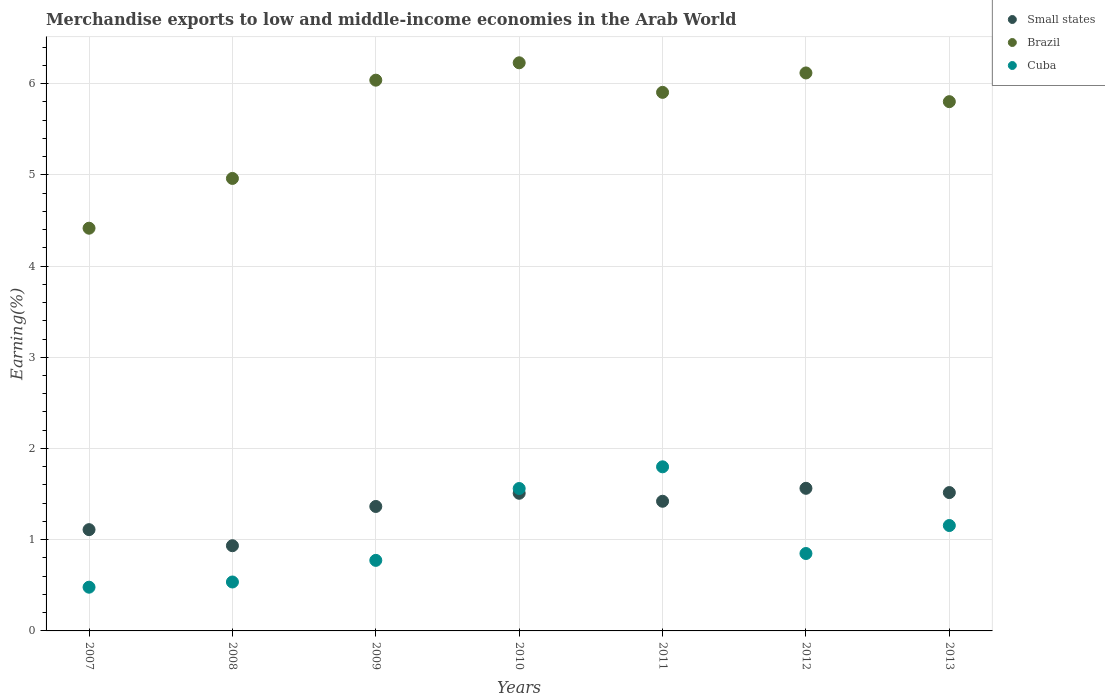What is the percentage of amount earned from merchandise exports in Small states in 2011?
Keep it short and to the point. 1.42. Across all years, what is the maximum percentage of amount earned from merchandise exports in Brazil?
Offer a terse response. 6.23. Across all years, what is the minimum percentage of amount earned from merchandise exports in Small states?
Offer a terse response. 0.93. In which year was the percentage of amount earned from merchandise exports in Brazil minimum?
Offer a very short reply. 2007. What is the total percentage of amount earned from merchandise exports in Small states in the graph?
Provide a succinct answer. 9.42. What is the difference between the percentage of amount earned from merchandise exports in Small states in 2011 and that in 2012?
Provide a succinct answer. -0.14. What is the difference between the percentage of amount earned from merchandise exports in Cuba in 2011 and the percentage of amount earned from merchandise exports in Small states in 2007?
Make the answer very short. 0.69. What is the average percentage of amount earned from merchandise exports in Small states per year?
Ensure brevity in your answer.  1.35. In the year 2013, what is the difference between the percentage of amount earned from merchandise exports in Brazil and percentage of amount earned from merchandise exports in Cuba?
Your answer should be compact. 4.65. What is the ratio of the percentage of amount earned from merchandise exports in Cuba in 2008 to that in 2011?
Your answer should be compact. 0.3. What is the difference between the highest and the second highest percentage of amount earned from merchandise exports in Brazil?
Provide a short and direct response. 0.11. What is the difference between the highest and the lowest percentage of amount earned from merchandise exports in Cuba?
Your answer should be very brief. 1.32. Is the percentage of amount earned from merchandise exports in Cuba strictly greater than the percentage of amount earned from merchandise exports in Small states over the years?
Keep it short and to the point. No. How many dotlines are there?
Give a very brief answer. 3. What is the difference between two consecutive major ticks on the Y-axis?
Ensure brevity in your answer.  1. Are the values on the major ticks of Y-axis written in scientific E-notation?
Offer a very short reply. No. Does the graph contain grids?
Your answer should be very brief. Yes. How are the legend labels stacked?
Provide a short and direct response. Vertical. What is the title of the graph?
Offer a terse response. Merchandise exports to low and middle-income economies in the Arab World. What is the label or title of the X-axis?
Your answer should be compact. Years. What is the label or title of the Y-axis?
Keep it short and to the point. Earning(%). What is the Earning(%) of Small states in 2007?
Provide a succinct answer. 1.11. What is the Earning(%) of Brazil in 2007?
Your answer should be very brief. 4.41. What is the Earning(%) of Cuba in 2007?
Offer a very short reply. 0.48. What is the Earning(%) in Small states in 2008?
Your answer should be compact. 0.93. What is the Earning(%) of Brazil in 2008?
Offer a terse response. 4.96. What is the Earning(%) of Cuba in 2008?
Make the answer very short. 0.54. What is the Earning(%) in Small states in 2009?
Your answer should be very brief. 1.36. What is the Earning(%) of Brazil in 2009?
Keep it short and to the point. 6.04. What is the Earning(%) of Cuba in 2009?
Keep it short and to the point. 0.77. What is the Earning(%) in Small states in 2010?
Provide a succinct answer. 1.51. What is the Earning(%) of Brazil in 2010?
Your answer should be compact. 6.23. What is the Earning(%) of Cuba in 2010?
Your response must be concise. 1.56. What is the Earning(%) of Small states in 2011?
Make the answer very short. 1.42. What is the Earning(%) of Brazil in 2011?
Make the answer very short. 5.9. What is the Earning(%) of Cuba in 2011?
Make the answer very short. 1.8. What is the Earning(%) in Small states in 2012?
Offer a very short reply. 1.56. What is the Earning(%) in Brazil in 2012?
Keep it short and to the point. 6.12. What is the Earning(%) in Cuba in 2012?
Offer a very short reply. 0.85. What is the Earning(%) in Small states in 2013?
Provide a succinct answer. 1.52. What is the Earning(%) of Brazil in 2013?
Make the answer very short. 5.8. What is the Earning(%) of Cuba in 2013?
Make the answer very short. 1.16. Across all years, what is the maximum Earning(%) of Small states?
Ensure brevity in your answer.  1.56. Across all years, what is the maximum Earning(%) of Brazil?
Keep it short and to the point. 6.23. Across all years, what is the maximum Earning(%) in Cuba?
Provide a short and direct response. 1.8. Across all years, what is the minimum Earning(%) of Small states?
Ensure brevity in your answer.  0.93. Across all years, what is the minimum Earning(%) in Brazil?
Your answer should be very brief. 4.41. Across all years, what is the minimum Earning(%) in Cuba?
Make the answer very short. 0.48. What is the total Earning(%) of Small states in the graph?
Your answer should be very brief. 9.42. What is the total Earning(%) of Brazil in the graph?
Offer a very short reply. 39.46. What is the total Earning(%) in Cuba in the graph?
Provide a succinct answer. 7.15. What is the difference between the Earning(%) of Small states in 2007 and that in 2008?
Provide a succinct answer. 0.18. What is the difference between the Earning(%) of Brazil in 2007 and that in 2008?
Keep it short and to the point. -0.55. What is the difference between the Earning(%) of Cuba in 2007 and that in 2008?
Your answer should be compact. -0.06. What is the difference between the Earning(%) in Small states in 2007 and that in 2009?
Provide a succinct answer. -0.25. What is the difference between the Earning(%) in Brazil in 2007 and that in 2009?
Your answer should be compact. -1.62. What is the difference between the Earning(%) of Cuba in 2007 and that in 2009?
Provide a succinct answer. -0.29. What is the difference between the Earning(%) of Small states in 2007 and that in 2010?
Your answer should be very brief. -0.4. What is the difference between the Earning(%) in Brazil in 2007 and that in 2010?
Provide a short and direct response. -1.81. What is the difference between the Earning(%) in Cuba in 2007 and that in 2010?
Provide a succinct answer. -1.08. What is the difference between the Earning(%) of Small states in 2007 and that in 2011?
Ensure brevity in your answer.  -0.31. What is the difference between the Earning(%) of Brazil in 2007 and that in 2011?
Your answer should be compact. -1.49. What is the difference between the Earning(%) in Cuba in 2007 and that in 2011?
Ensure brevity in your answer.  -1.32. What is the difference between the Earning(%) of Small states in 2007 and that in 2012?
Your answer should be very brief. -0.45. What is the difference between the Earning(%) of Brazil in 2007 and that in 2012?
Offer a terse response. -1.7. What is the difference between the Earning(%) of Cuba in 2007 and that in 2012?
Make the answer very short. -0.37. What is the difference between the Earning(%) of Small states in 2007 and that in 2013?
Offer a very short reply. -0.41. What is the difference between the Earning(%) in Brazil in 2007 and that in 2013?
Offer a very short reply. -1.39. What is the difference between the Earning(%) of Cuba in 2007 and that in 2013?
Give a very brief answer. -0.68. What is the difference between the Earning(%) of Small states in 2008 and that in 2009?
Give a very brief answer. -0.43. What is the difference between the Earning(%) of Brazil in 2008 and that in 2009?
Give a very brief answer. -1.08. What is the difference between the Earning(%) of Cuba in 2008 and that in 2009?
Your answer should be very brief. -0.24. What is the difference between the Earning(%) in Small states in 2008 and that in 2010?
Provide a short and direct response. -0.57. What is the difference between the Earning(%) in Brazil in 2008 and that in 2010?
Offer a terse response. -1.27. What is the difference between the Earning(%) of Cuba in 2008 and that in 2010?
Give a very brief answer. -1.02. What is the difference between the Earning(%) of Small states in 2008 and that in 2011?
Give a very brief answer. -0.49. What is the difference between the Earning(%) of Brazil in 2008 and that in 2011?
Give a very brief answer. -0.94. What is the difference between the Earning(%) in Cuba in 2008 and that in 2011?
Your response must be concise. -1.26. What is the difference between the Earning(%) in Small states in 2008 and that in 2012?
Provide a short and direct response. -0.63. What is the difference between the Earning(%) of Brazil in 2008 and that in 2012?
Offer a terse response. -1.16. What is the difference between the Earning(%) of Cuba in 2008 and that in 2012?
Make the answer very short. -0.31. What is the difference between the Earning(%) of Small states in 2008 and that in 2013?
Your answer should be very brief. -0.58. What is the difference between the Earning(%) of Brazil in 2008 and that in 2013?
Keep it short and to the point. -0.84. What is the difference between the Earning(%) of Cuba in 2008 and that in 2013?
Give a very brief answer. -0.62. What is the difference between the Earning(%) of Small states in 2009 and that in 2010?
Provide a succinct answer. -0.14. What is the difference between the Earning(%) in Brazil in 2009 and that in 2010?
Offer a very short reply. -0.19. What is the difference between the Earning(%) of Cuba in 2009 and that in 2010?
Keep it short and to the point. -0.79. What is the difference between the Earning(%) of Small states in 2009 and that in 2011?
Keep it short and to the point. -0.06. What is the difference between the Earning(%) of Brazil in 2009 and that in 2011?
Give a very brief answer. 0.13. What is the difference between the Earning(%) of Cuba in 2009 and that in 2011?
Offer a very short reply. -1.03. What is the difference between the Earning(%) of Small states in 2009 and that in 2012?
Your response must be concise. -0.2. What is the difference between the Earning(%) of Brazil in 2009 and that in 2012?
Provide a short and direct response. -0.08. What is the difference between the Earning(%) in Cuba in 2009 and that in 2012?
Keep it short and to the point. -0.08. What is the difference between the Earning(%) of Small states in 2009 and that in 2013?
Your answer should be compact. -0.15. What is the difference between the Earning(%) of Brazil in 2009 and that in 2013?
Give a very brief answer. 0.24. What is the difference between the Earning(%) in Cuba in 2009 and that in 2013?
Offer a very short reply. -0.38. What is the difference between the Earning(%) of Small states in 2010 and that in 2011?
Keep it short and to the point. 0.09. What is the difference between the Earning(%) of Brazil in 2010 and that in 2011?
Offer a terse response. 0.32. What is the difference between the Earning(%) in Cuba in 2010 and that in 2011?
Keep it short and to the point. -0.24. What is the difference between the Earning(%) of Small states in 2010 and that in 2012?
Ensure brevity in your answer.  -0.05. What is the difference between the Earning(%) of Brazil in 2010 and that in 2012?
Your response must be concise. 0.11. What is the difference between the Earning(%) of Cuba in 2010 and that in 2012?
Your answer should be compact. 0.71. What is the difference between the Earning(%) of Small states in 2010 and that in 2013?
Your answer should be compact. -0.01. What is the difference between the Earning(%) of Brazil in 2010 and that in 2013?
Make the answer very short. 0.43. What is the difference between the Earning(%) in Cuba in 2010 and that in 2013?
Make the answer very short. 0.41. What is the difference between the Earning(%) of Small states in 2011 and that in 2012?
Your answer should be compact. -0.14. What is the difference between the Earning(%) in Brazil in 2011 and that in 2012?
Your answer should be compact. -0.21. What is the difference between the Earning(%) in Cuba in 2011 and that in 2012?
Give a very brief answer. 0.95. What is the difference between the Earning(%) of Small states in 2011 and that in 2013?
Keep it short and to the point. -0.1. What is the difference between the Earning(%) of Brazil in 2011 and that in 2013?
Ensure brevity in your answer.  0.1. What is the difference between the Earning(%) of Cuba in 2011 and that in 2013?
Ensure brevity in your answer.  0.64. What is the difference between the Earning(%) in Small states in 2012 and that in 2013?
Offer a terse response. 0.05. What is the difference between the Earning(%) in Brazil in 2012 and that in 2013?
Offer a terse response. 0.31. What is the difference between the Earning(%) of Cuba in 2012 and that in 2013?
Ensure brevity in your answer.  -0.31. What is the difference between the Earning(%) of Small states in 2007 and the Earning(%) of Brazil in 2008?
Your answer should be very brief. -3.85. What is the difference between the Earning(%) of Small states in 2007 and the Earning(%) of Cuba in 2008?
Make the answer very short. 0.57. What is the difference between the Earning(%) of Brazil in 2007 and the Earning(%) of Cuba in 2008?
Your response must be concise. 3.88. What is the difference between the Earning(%) of Small states in 2007 and the Earning(%) of Brazil in 2009?
Make the answer very short. -4.93. What is the difference between the Earning(%) in Small states in 2007 and the Earning(%) in Cuba in 2009?
Ensure brevity in your answer.  0.34. What is the difference between the Earning(%) of Brazil in 2007 and the Earning(%) of Cuba in 2009?
Offer a terse response. 3.64. What is the difference between the Earning(%) of Small states in 2007 and the Earning(%) of Brazil in 2010?
Offer a very short reply. -5.12. What is the difference between the Earning(%) in Small states in 2007 and the Earning(%) in Cuba in 2010?
Make the answer very short. -0.45. What is the difference between the Earning(%) of Brazil in 2007 and the Earning(%) of Cuba in 2010?
Your answer should be very brief. 2.85. What is the difference between the Earning(%) of Small states in 2007 and the Earning(%) of Brazil in 2011?
Provide a succinct answer. -4.79. What is the difference between the Earning(%) in Small states in 2007 and the Earning(%) in Cuba in 2011?
Keep it short and to the point. -0.69. What is the difference between the Earning(%) of Brazil in 2007 and the Earning(%) of Cuba in 2011?
Your response must be concise. 2.62. What is the difference between the Earning(%) in Small states in 2007 and the Earning(%) in Brazil in 2012?
Make the answer very short. -5.01. What is the difference between the Earning(%) in Small states in 2007 and the Earning(%) in Cuba in 2012?
Offer a terse response. 0.26. What is the difference between the Earning(%) in Brazil in 2007 and the Earning(%) in Cuba in 2012?
Keep it short and to the point. 3.57. What is the difference between the Earning(%) of Small states in 2007 and the Earning(%) of Brazil in 2013?
Provide a short and direct response. -4.69. What is the difference between the Earning(%) of Small states in 2007 and the Earning(%) of Cuba in 2013?
Provide a short and direct response. -0.05. What is the difference between the Earning(%) of Brazil in 2007 and the Earning(%) of Cuba in 2013?
Provide a short and direct response. 3.26. What is the difference between the Earning(%) in Small states in 2008 and the Earning(%) in Brazil in 2009?
Offer a terse response. -5.1. What is the difference between the Earning(%) in Small states in 2008 and the Earning(%) in Cuba in 2009?
Your response must be concise. 0.16. What is the difference between the Earning(%) of Brazil in 2008 and the Earning(%) of Cuba in 2009?
Provide a short and direct response. 4.19. What is the difference between the Earning(%) in Small states in 2008 and the Earning(%) in Brazil in 2010?
Your answer should be compact. -5.29. What is the difference between the Earning(%) of Small states in 2008 and the Earning(%) of Cuba in 2010?
Offer a very short reply. -0.63. What is the difference between the Earning(%) in Brazil in 2008 and the Earning(%) in Cuba in 2010?
Ensure brevity in your answer.  3.4. What is the difference between the Earning(%) of Small states in 2008 and the Earning(%) of Brazil in 2011?
Ensure brevity in your answer.  -4.97. What is the difference between the Earning(%) of Small states in 2008 and the Earning(%) of Cuba in 2011?
Keep it short and to the point. -0.86. What is the difference between the Earning(%) of Brazil in 2008 and the Earning(%) of Cuba in 2011?
Ensure brevity in your answer.  3.16. What is the difference between the Earning(%) in Small states in 2008 and the Earning(%) in Brazil in 2012?
Offer a very short reply. -5.18. What is the difference between the Earning(%) of Small states in 2008 and the Earning(%) of Cuba in 2012?
Your answer should be compact. 0.09. What is the difference between the Earning(%) in Brazil in 2008 and the Earning(%) in Cuba in 2012?
Ensure brevity in your answer.  4.11. What is the difference between the Earning(%) in Small states in 2008 and the Earning(%) in Brazil in 2013?
Make the answer very short. -4.87. What is the difference between the Earning(%) in Small states in 2008 and the Earning(%) in Cuba in 2013?
Your answer should be very brief. -0.22. What is the difference between the Earning(%) of Brazil in 2008 and the Earning(%) of Cuba in 2013?
Offer a very short reply. 3.8. What is the difference between the Earning(%) in Small states in 2009 and the Earning(%) in Brazil in 2010?
Make the answer very short. -4.86. What is the difference between the Earning(%) of Small states in 2009 and the Earning(%) of Cuba in 2010?
Your answer should be compact. -0.2. What is the difference between the Earning(%) of Brazil in 2009 and the Earning(%) of Cuba in 2010?
Provide a short and direct response. 4.48. What is the difference between the Earning(%) of Small states in 2009 and the Earning(%) of Brazil in 2011?
Your answer should be compact. -4.54. What is the difference between the Earning(%) of Small states in 2009 and the Earning(%) of Cuba in 2011?
Offer a very short reply. -0.43. What is the difference between the Earning(%) of Brazil in 2009 and the Earning(%) of Cuba in 2011?
Your answer should be compact. 4.24. What is the difference between the Earning(%) of Small states in 2009 and the Earning(%) of Brazil in 2012?
Give a very brief answer. -4.75. What is the difference between the Earning(%) in Small states in 2009 and the Earning(%) in Cuba in 2012?
Ensure brevity in your answer.  0.52. What is the difference between the Earning(%) in Brazil in 2009 and the Earning(%) in Cuba in 2012?
Give a very brief answer. 5.19. What is the difference between the Earning(%) in Small states in 2009 and the Earning(%) in Brazil in 2013?
Your answer should be very brief. -4.44. What is the difference between the Earning(%) in Small states in 2009 and the Earning(%) in Cuba in 2013?
Ensure brevity in your answer.  0.21. What is the difference between the Earning(%) in Brazil in 2009 and the Earning(%) in Cuba in 2013?
Ensure brevity in your answer.  4.88. What is the difference between the Earning(%) of Small states in 2010 and the Earning(%) of Brazil in 2011?
Give a very brief answer. -4.39. What is the difference between the Earning(%) of Small states in 2010 and the Earning(%) of Cuba in 2011?
Your response must be concise. -0.29. What is the difference between the Earning(%) in Brazil in 2010 and the Earning(%) in Cuba in 2011?
Offer a very short reply. 4.43. What is the difference between the Earning(%) of Small states in 2010 and the Earning(%) of Brazil in 2012?
Your response must be concise. -4.61. What is the difference between the Earning(%) of Small states in 2010 and the Earning(%) of Cuba in 2012?
Keep it short and to the point. 0.66. What is the difference between the Earning(%) in Brazil in 2010 and the Earning(%) in Cuba in 2012?
Make the answer very short. 5.38. What is the difference between the Earning(%) of Small states in 2010 and the Earning(%) of Brazil in 2013?
Ensure brevity in your answer.  -4.29. What is the difference between the Earning(%) in Small states in 2010 and the Earning(%) in Cuba in 2013?
Give a very brief answer. 0.35. What is the difference between the Earning(%) of Brazil in 2010 and the Earning(%) of Cuba in 2013?
Make the answer very short. 5.07. What is the difference between the Earning(%) in Small states in 2011 and the Earning(%) in Brazil in 2012?
Keep it short and to the point. -4.7. What is the difference between the Earning(%) in Small states in 2011 and the Earning(%) in Cuba in 2012?
Your answer should be compact. 0.57. What is the difference between the Earning(%) of Brazil in 2011 and the Earning(%) of Cuba in 2012?
Your response must be concise. 5.06. What is the difference between the Earning(%) in Small states in 2011 and the Earning(%) in Brazil in 2013?
Your response must be concise. -4.38. What is the difference between the Earning(%) in Small states in 2011 and the Earning(%) in Cuba in 2013?
Provide a short and direct response. 0.27. What is the difference between the Earning(%) of Brazil in 2011 and the Earning(%) of Cuba in 2013?
Your answer should be very brief. 4.75. What is the difference between the Earning(%) in Small states in 2012 and the Earning(%) in Brazil in 2013?
Make the answer very short. -4.24. What is the difference between the Earning(%) in Small states in 2012 and the Earning(%) in Cuba in 2013?
Offer a very short reply. 0.41. What is the difference between the Earning(%) in Brazil in 2012 and the Earning(%) in Cuba in 2013?
Ensure brevity in your answer.  4.96. What is the average Earning(%) in Small states per year?
Your response must be concise. 1.35. What is the average Earning(%) in Brazil per year?
Make the answer very short. 5.64. What is the average Earning(%) of Cuba per year?
Your answer should be compact. 1.02. In the year 2007, what is the difference between the Earning(%) of Small states and Earning(%) of Brazil?
Your response must be concise. -3.3. In the year 2007, what is the difference between the Earning(%) of Small states and Earning(%) of Cuba?
Provide a succinct answer. 0.63. In the year 2007, what is the difference between the Earning(%) in Brazil and Earning(%) in Cuba?
Keep it short and to the point. 3.94. In the year 2008, what is the difference between the Earning(%) of Small states and Earning(%) of Brazil?
Your answer should be very brief. -4.03. In the year 2008, what is the difference between the Earning(%) in Small states and Earning(%) in Cuba?
Offer a terse response. 0.4. In the year 2008, what is the difference between the Earning(%) of Brazil and Earning(%) of Cuba?
Offer a terse response. 4.42. In the year 2009, what is the difference between the Earning(%) of Small states and Earning(%) of Brazil?
Keep it short and to the point. -4.67. In the year 2009, what is the difference between the Earning(%) of Small states and Earning(%) of Cuba?
Your answer should be very brief. 0.59. In the year 2009, what is the difference between the Earning(%) of Brazil and Earning(%) of Cuba?
Your answer should be very brief. 5.26. In the year 2010, what is the difference between the Earning(%) in Small states and Earning(%) in Brazil?
Ensure brevity in your answer.  -4.72. In the year 2010, what is the difference between the Earning(%) in Small states and Earning(%) in Cuba?
Offer a terse response. -0.05. In the year 2010, what is the difference between the Earning(%) of Brazil and Earning(%) of Cuba?
Ensure brevity in your answer.  4.67. In the year 2011, what is the difference between the Earning(%) of Small states and Earning(%) of Brazil?
Offer a very short reply. -4.48. In the year 2011, what is the difference between the Earning(%) in Small states and Earning(%) in Cuba?
Your answer should be compact. -0.38. In the year 2011, what is the difference between the Earning(%) of Brazil and Earning(%) of Cuba?
Make the answer very short. 4.1. In the year 2012, what is the difference between the Earning(%) of Small states and Earning(%) of Brazil?
Offer a terse response. -4.55. In the year 2012, what is the difference between the Earning(%) in Small states and Earning(%) in Cuba?
Your response must be concise. 0.71. In the year 2012, what is the difference between the Earning(%) in Brazil and Earning(%) in Cuba?
Your answer should be very brief. 5.27. In the year 2013, what is the difference between the Earning(%) in Small states and Earning(%) in Brazil?
Your answer should be compact. -4.29. In the year 2013, what is the difference between the Earning(%) of Small states and Earning(%) of Cuba?
Make the answer very short. 0.36. In the year 2013, what is the difference between the Earning(%) in Brazil and Earning(%) in Cuba?
Your answer should be very brief. 4.65. What is the ratio of the Earning(%) in Small states in 2007 to that in 2008?
Your answer should be very brief. 1.19. What is the ratio of the Earning(%) of Brazil in 2007 to that in 2008?
Provide a short and direct response. 0.89. What is the ratio of the Earning(%) in Cuba in 2007 to that in 2008?
Your answer should be very brief. 0.89. What is the ratio of the Earning(%) in Small states in 2007 to that in 2009?
Offer a terse response. 0.81. What is the ratio of the Earning(%) of Brazil in 2007 to that in 2009?
Offer a terse response. 0.73. What is the ratio of the Earning(%) of Cuba in 2007 to that in 2009?
Make the answer very short. 0.62. What is the ratio of the Earning(%) in Small states in 2007 to that in 2010?
Provide a short and direct response. 0.74. What is the ratio of the Earning(%) in Brazil in 2007 to that in 2010?
Ensure brevity in your answer.  0.71. What is the ratio of the Earning(%) in Cuba in 2007 to that in 2010?
Give a very brief answer. 0.31. What is the ratio of the Earning(%) in Small states in 2007 to that in 2011?
Provide a short and direct response. 0.78. What is the ratio of the Earning(%) of Brazil in 2007 to that in 2011?
Your response must be concise. 0.75. What is the ratio of the Earning(%) in Cuba in 2007 to that in 2011?
Keep it short and to the point. 0.27. What is the ratio of the Earning(%) of Small states in 2007 to that in 2012?
Provide a succinct answer. 0.71. What is the ratio of the Earning(%) in Brazil in 2007 to that in 2012?
Give a very brief answer. 0.72. What is the ratio of the Earning(%) of Cuba in 2007 to that in 2012?
Make the answer very short. 0.56. What is the ratio of the Earning(%) in Small states in 2007 to that in 2013?
Offer a terse response. 0.73. What is the ratio of the Earning(%) in Brazil in 2007 to that in 2013?
Provide a short and direct response. 0.76. What is the ratio of the Earning(%) in Cuba in 2007 to that in 2013?
Your response must be concise. 0.41. What is the ratio of the Earning(%) of Small states in 2008 to that in 2009?
Give a very brief answer. 0.68. What is the ratio of the Earning(%) in Brazil in 2008 to that in 2009?
Your response must be concise. 0.82. What is the ratio of the Earning(%) in Cuba in 2008 to that in 2009?
Your answer should be very brief. 0.69. What is the ratio of the Earning(%) in Small states in 2008 to that in 2010?
Offer a very short reply. 0.62. What is the ratio of the Earning(%) in Brazil in 2008 to that in 2010?
Offer a very short reply. 0.8. What is the ratio of the Earning(%) of Cuba in 2008 to that in 2010?
Ensure brevity in your answer.  0.34. What is the ratio of the Earning(%) of Small states in 2008 to that in 2011?
Give a very brief answer. 0.66. What is the ratio of the Earning(%) of Brazil in 2008 to that in 2011?
Your response must be concise. 0.84. What is the ratio of the Earning(%) in Cuba in 2008 to that in 2011?
Give a very brief answer. 0.3. What is the ratio of the Earning(%) in Small states in 2008 to that in 2012?
Provide a succinct answer. 0.6. What is the ratio of the Earning(%) of Brazil in 2008 to that in 2012?
Provide a short and direct response. 0.81. What is the ratio of the Earning(%) of Cuba in 2008 to that in 2012?
Keep it short and to the point. 0.63. What is the ratio of the Earning(%) of Small states in 2008 to that in 2013?
Offer a very short reply. 0.62. What is the ratio of the Earning(%) of Brazil in 2008 to that in 2013?
Your answer should be compact. 0.85. What is the ratio of the Earning(%) in Cuba in 2008 to that in 2013?
Offer a terse response. 0.46. What is the ratio of the Earning(%) in Small states in 2009 to that in 2010?
Offer a very short reply. 0.9. What is the ratio of the Earning(%) of Brazil in 2009 to that in 2010?
Keep it short and to the point. 0.97. What is the ratio of the Earning(%) of Cuba in 2009 to that in 2010?
Offer a terse response. 0.5. What is the ratio of the Earning(%) in Small states in 2009 to that in 2011?
Give a very brief answer. 0.96. What is the ratio of the Earning(%) in Brazil in 2009 to that in 2011?
Give a very brief answer. 1.02. What is the ratio of the Earning(%) in Cuba in 2009 to that in 2011?
Make the answer very short. 0.43. What is the ratio of the Earning(%) in Small states in 2009 to that in 2012?
Offer a terse response. 0.87. What is the ratio of the Earning(%) in Brazil in 2009 to that in 2012?
Provide a short and direct response. 0.99. What is the ratio of the Earning(%) of Cuba in 2009 to that in 2012?
Ensure brevity in your answer.  0.91. What is the ratio of the Earning(%) of Small states in 2009 to that in 2013?
Provide a short and direct response. 0.9. What is the ratio of the Earning(%) in Brazil in 2009 to that in 2013?
Offer a terse response. 1.04. What is the ratio of the Earning(%) in Cuba in 2009 to that in 2013?
Keep it short and to the point. 0.67. What is the ratio of the Earning(%) in Small states in 2010 to that in 2011?
Your response must be concise. 1.06. What is the ratio of the Earning(%) of Brazil in 2010 to that in 2011?
Make the answer very short. 1.05. What is the ratio of the Earning(%) in Cuba in 2010 to that in 2011?
Your response must be concise. 0.87. What is the ratio of the Earning(%) of Small states in 2010 to that in 2012?
Provide a short and direct response. 0.97. What is the ratio of the Earning(%) in Brazil in 2010 to that in 2012?
Your answer should be very brief. 1.02. What is the ratio of the Earning(%) in Cuba in 2010 to that in 2012?
Make the answer very short. 1.84. What is the ratio of the Earning(%) in Brazil in 2010 to that in 2013?
Offer a very short reply. 1.07. What is the ratio of the Earning(%) in Cuba in 2010 to that in 2013?
Provide a succinct answer. 1.35. What is the ratio of the Earning(%) in Small states in 2011 to that in 2012?
Your response must be concise. 0.91. What is the ratio of the Earning(%) in Brazil in 2011 to that in 2012?
Provide a succinct answer. 0.97. What is the ratio of the Earning(%) of Cuba in 2011 to that in 2012?
Make the answer very short. 2.12. What is the ratio of the Earning(%) of Small states in 2011 to that in 2013?
Give a very brief answer. 0.94. What is the ratio of the Earning(%) of Brazil in 2011 to that in 2013?
Your response must be concise. 1.02. What is the ratio of the Earning(%) in Cuba in 2011 to that in 2013?
Keep it short and to the point. 1.56. What is the ratio of the Earning(%) in Small states in 2012 to that in 2013?
Ensure brevity in your answer.  1.03. What is the ratio of the Earning(%) in Brazil in 2012 to that in 2013?
Your answer should be very brief. 1.05. What is the ratio of the Earning(%) in Cuba in 2012 to that in 2013?
Keep it short and to the point. 0.73. What is the difference between the highest and the second highest Earning(%) of Small states?
Offer a very short reply. 0.05. What is the difference between the highest and the second highest Earning(%) in Brazil?
Make the answer very short. 0.11. What is the difference between the highest and the second highest Earning(%) of Cuba?
Your answer should be very brief. 0.24. What is the difference between the highest and the lowest Earning(%) of Small states?
Provide a succinct answer. 0.63. What is the difference between the highest and the lowest Earning(%) in Brazil?
Give a very brief answer. 1.81. What is the difference between the highest and the lowest Earning(%) in Cuba?
Your response must be concise. 1.32. 